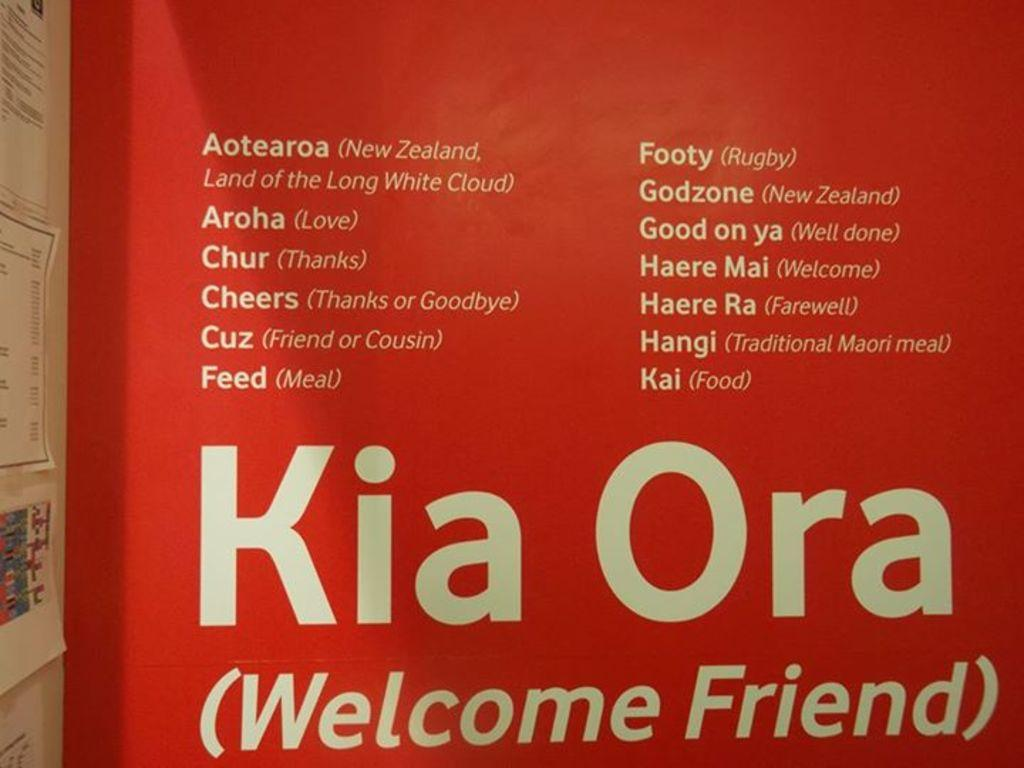What is the main object in the image? There is a hoarding in the image. What can be seen on the hoarding? There is writing on the hoarding. What else is present on the left side of the image? There are posters on the left side of the image. How many beds can be seen in the image? There are no beds present in the image. Is there a jail visible in the image? There is no jail visible in the image. 